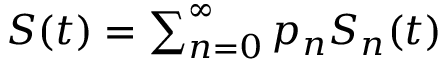Convert formula to latex. <formula><loc_0><loc_0><loc_500><loc_500>\begin{array} { r } { S ( t ) = \sum _ { n = 0 } ^ { \infty } p _ { n } S _ { n } ( t ) } \end{array}</formula> 